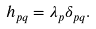<formula> <loc_0><loc_0><loc_500><loc_500>h _ { p q } = \lambda _ { p } \delta _ { p q } .</formula> 